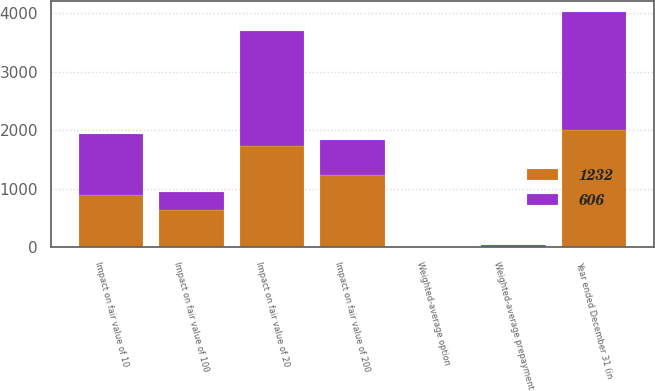<chart> <loc_0><loc_0><loc_500><loc_500><stacked_bar_chart><ecel><fcel>Year ended December 31 (in<fcel>Weighted-average prepayment<fcel>Impact on fair value of 10<fcel>Impact on fair value of 20<fcel>Weighted-average option<fcel>Impact on fair value of 100<fcel>Impact on fair value of 200<nl><fcel>1232<fcel>2009<fcel>11.37<fcel>896<fcel>1731<fcel>4.63<fcel>641<fcel>1232<nl><fcel>606<fcel>2008<fcel>35.21<fcel>1039<fcel>1970<fcel>3.8<fcel>311<fcel>606<nl></chart> 